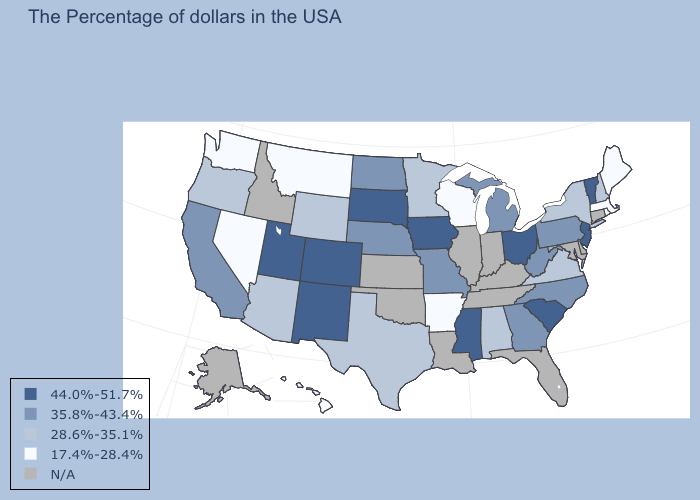What is the value of West Virginia?
Quick response, please. 35.8%-43.4%. What is the value of Arkansas?
Keep it brief. 17.4%-28.4%. What is the value of Arkansas?
Write a very short answer. 17.4%-28.4%. Which states hav the highest value in the Northeast?
Concise answer only. Vermont, New Jersey. Name the states that have a value in the range 35.8%-43.4%?
Concise answer only. Pennsylvania, North Carolina, West Virginia, Georgia, Michigan, Missouri, Nebraska, North Dakota, California. What is the value of Connecticut?
Keep it brief. N/A. Does Vermont have the lowest value in the Northeast?
Be succinct. No. What is the highest value in states that border Vermont?
Concise answer only. 28.6%-35.1%. Which states have the lowest value in the USA?
Answer briefly. Maine, Massachusetts, Rhode Island, Wisconsin, Arkansas, Montana, Nevada, Washington, Hawaii. Does Ohio have the highest value in the USA?
Short answer required. Yes. What is the value of Montana?
Concise answer only. 17.4%-28.4%. Is the legend a continuous bar?
Write a very short answer. No. 